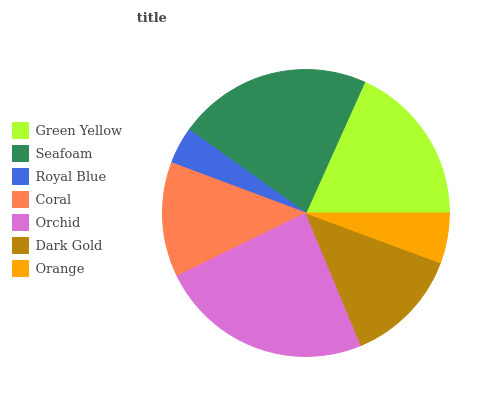Is Royal Blue the minimum?
Answer yes or no. Yes. Is Orchid the maximum?
Answer yes or no. Yes. Is Seafoam the minimum?
Answer yes or no. No. Is Seafoam the maximum?
Answer yes or no. No. Is Seafoam greater than Green Yellow?
Answer yes or no. Yes. Is Green Yellow less than Seafoam?
Answer yes or no. Yes. Is Green Yellow greater than Seafoam?
Answer yes or no. No. Is Seafoam less than Green Yellow?
Answer yes or no. No. Is Dark Gold the high median?
Answer yes or no. Yes. Is Dark Gold the low median?
Answer yes or no. Yes. Is Orange the high median?
Answer yes or no. No. Is Royal Blue the low median?
Answer yes or no. No. 